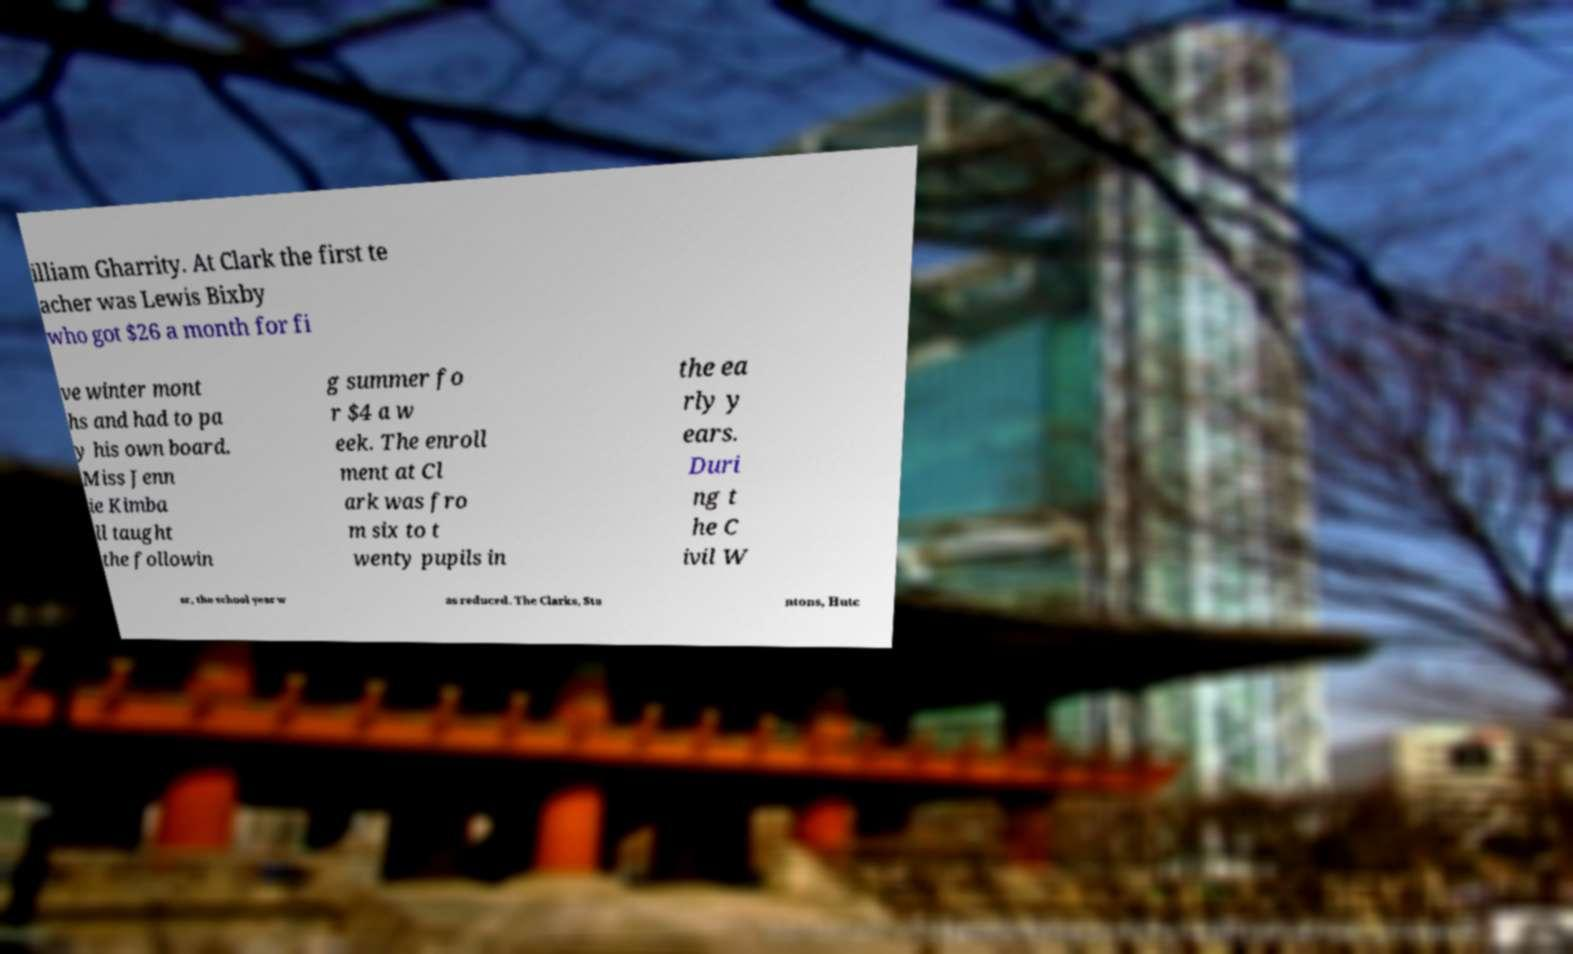Please read and relay the text visible in this image. What does it say? illiam Gharrity. At Clark the first te acher was Lewis Bixby who got $26 a month for fi ve winter mont hs and had to pa y his own board. Miss Jenn ie Kimba ll taught the followin g summer fo r $4 a w eek. The enroll ment at Cl ark was fro m six to t wenty pupils in the ea rly y ears. Duri ng t he C ivil W ar, the school year w as reduced. The Clarks, Sta ntons, Hutc 